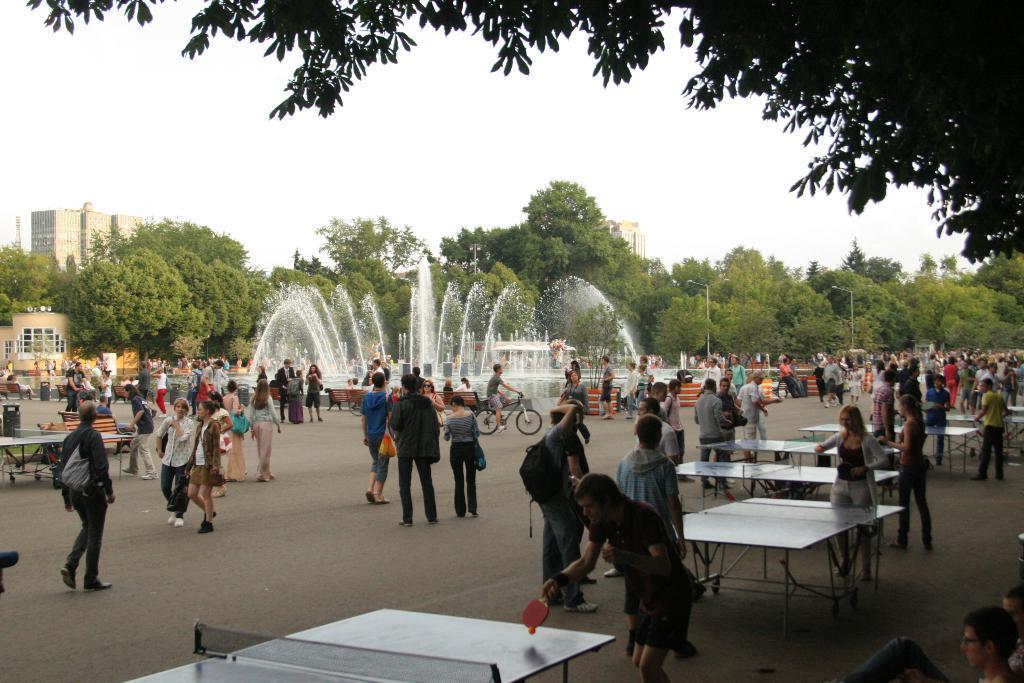In one or two sentences, can you explain what this image depicts? this is a image of a out side of a city and there is a sky visible and there is a fountain visible and there are the people stand and walking on the road and there are some trees and buildings visible and there are some tables kept on the floor and there are some persons playing a game 